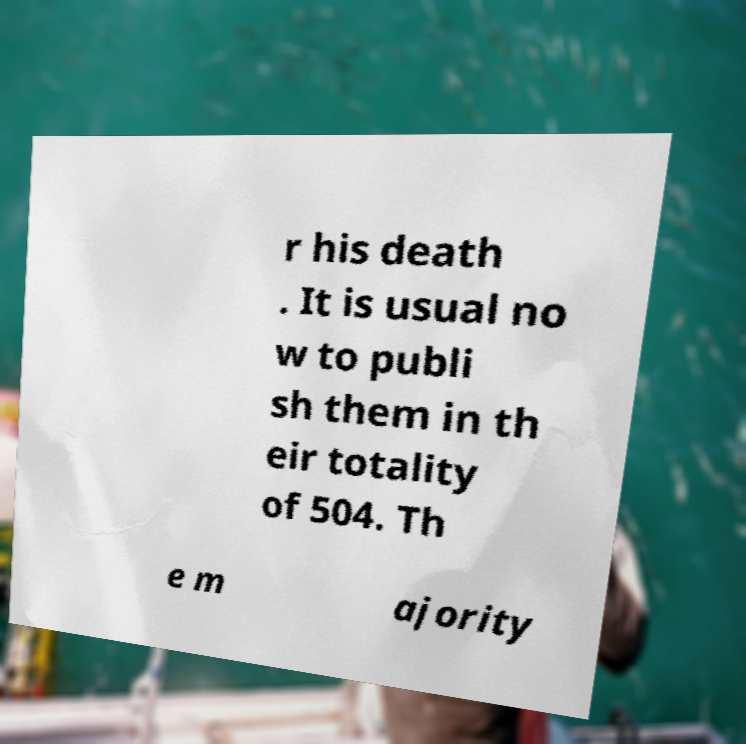Please read and relay the text visible in this image. What does it say? r his death . It is usual no w to publi sh them in th eir totality of 504. Th e m ajority 